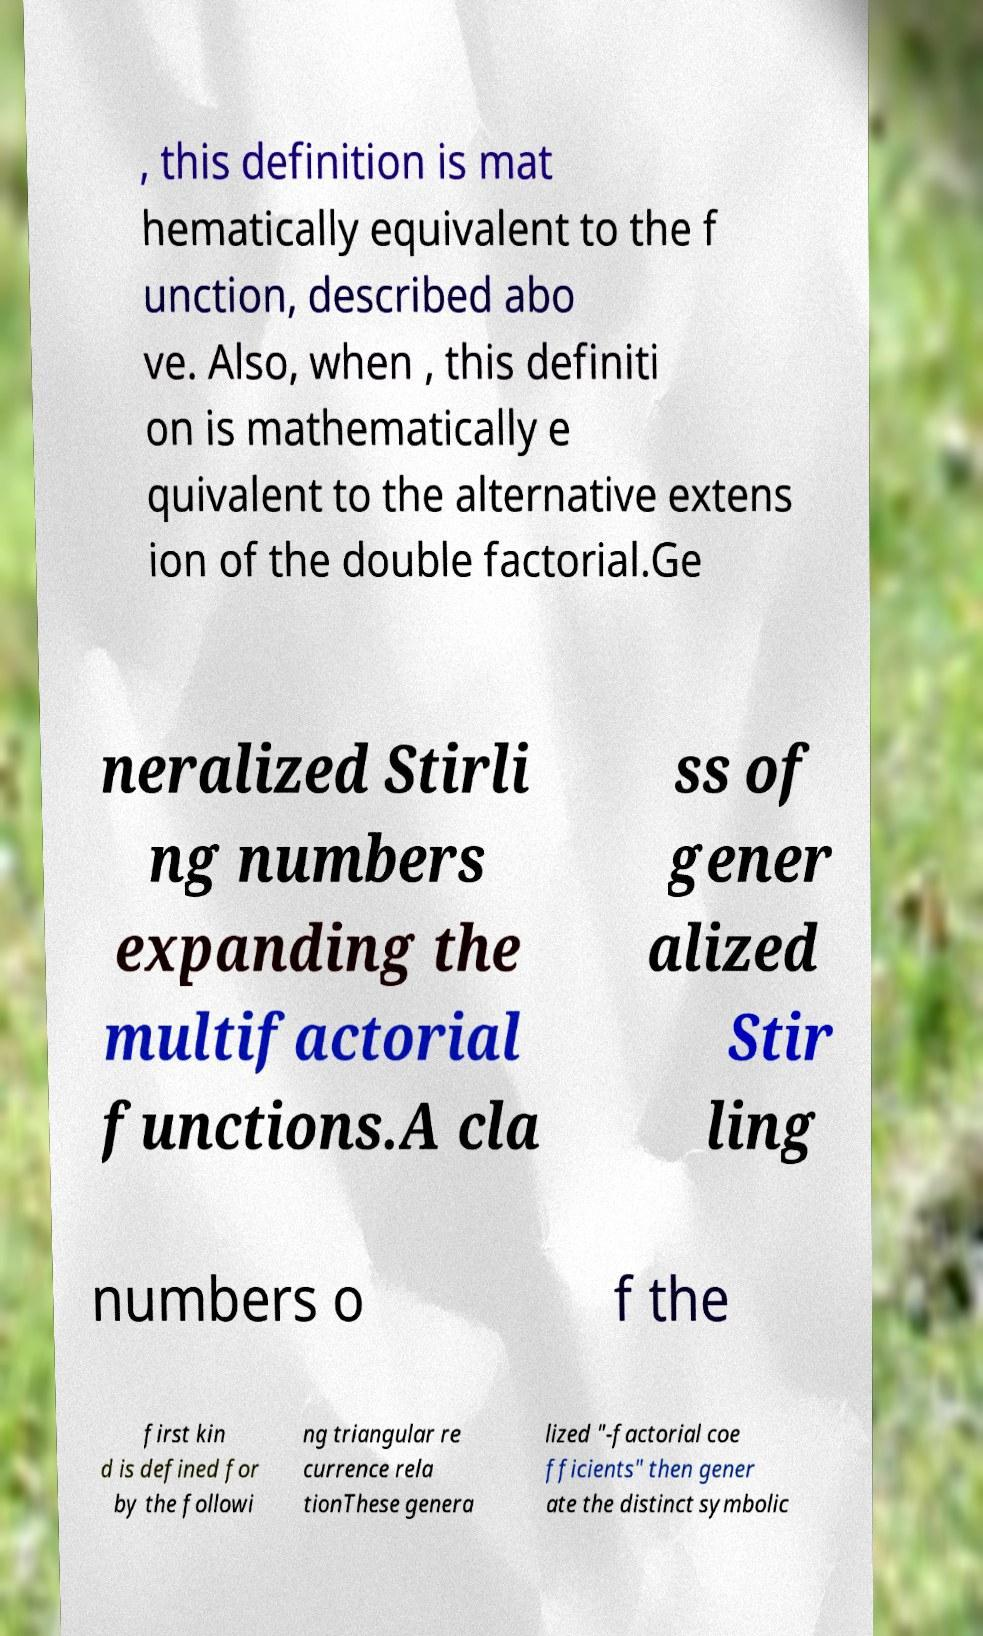Could you extract and type out the text from this image? , this definition is mat hematically equivalent to the f unction, described abo ve. Also, when , this definiti on is mathematically e quivalent to the alternative extens ion of the double factorial.Ge neralized Stirli ng numbers expanding the multifactorial functions.A cla ss of gener alized Stir ling numbers o f the first kin d is defined for by the followi ng triangular re currence rela tionThese genera lized "-factorial coe fficients" then gener ate the distinct symbolic 